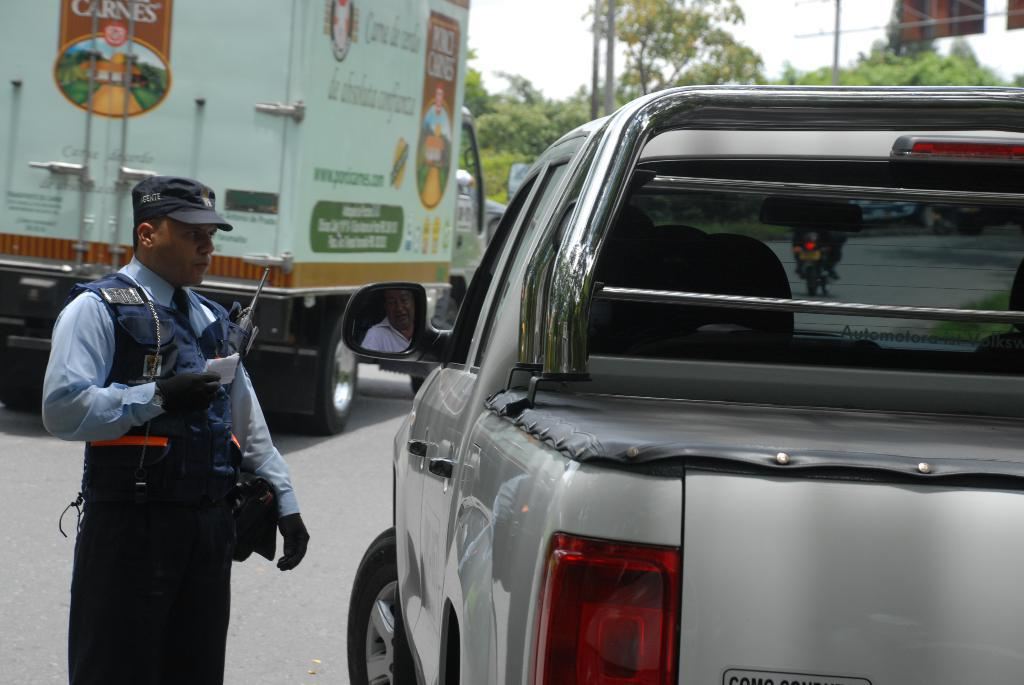What is the main subject of the image? There is a person standing in the image. What else can be seen in the image besides the person? There are vehicles on the road and trees in the image. What is visible in the background of the image? The sky is visible in the background of the image. How many ants can be seen carrying the news on the scale in the image? There are no ants, news, or scales present in the image. 